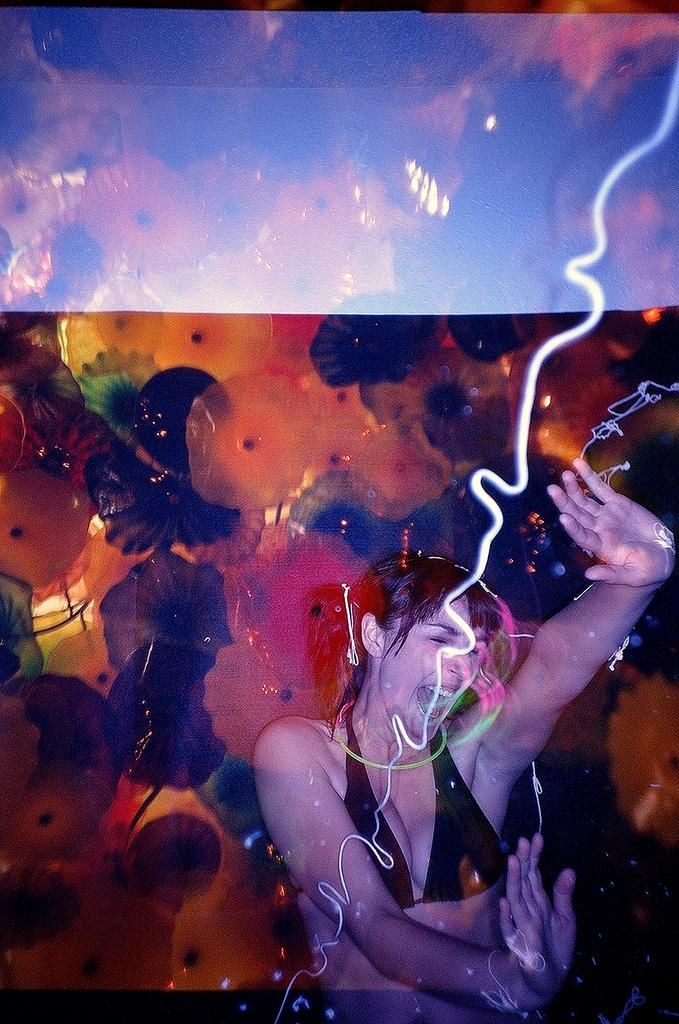What can be observed about the image's appearance? The image appears to be edited. What activity is the woman at the bottom of the image engaged in? The woman is dancing at the bottom of the image. What type of objects can be seen at the top of the image? There are decorative items at the top of the image. Is there any visible dust on the decorative items at the top of the image? There is no mention of dust in the image, and the image appears to be edited, so it is not possible to determine if there is any visible dust. 